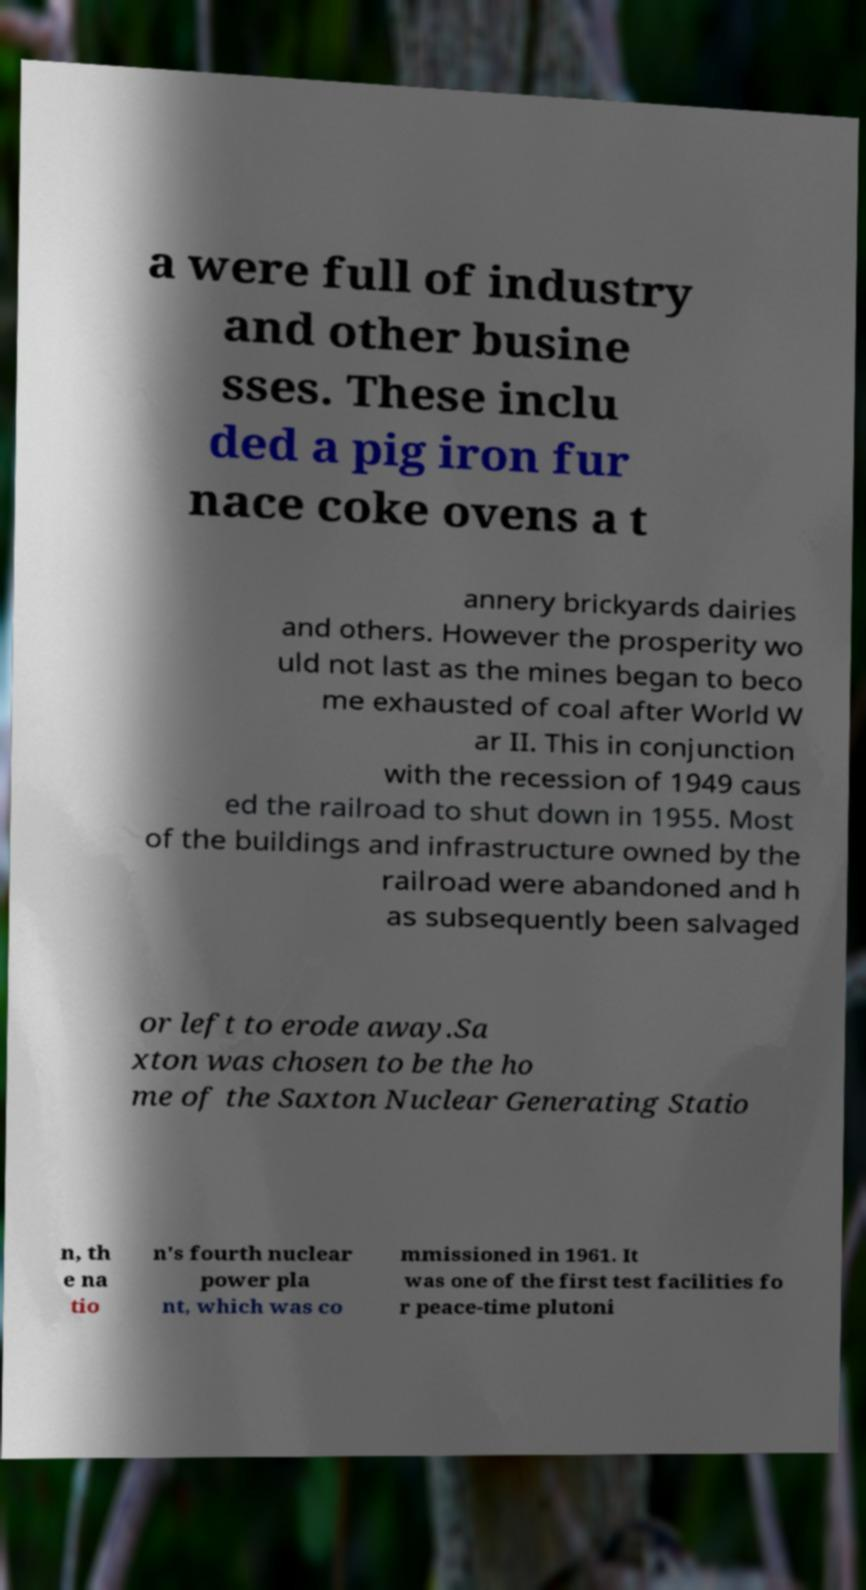For documentation purposes, I need the text within this image transcribed. Could you provide that? a were full of industry and other busine sses. These inclu ded a pig iron fur nace coke ovens a t annery brickyards dairies and others. However the prosperity wo uld not last as the mines began to beco me exhausted of coal after World W ar II. This in conjunction with the recession of 1949 caus ed the railroad to shut down in 1955. Most of the buildings and infrastructure owned by the railroad were abandoned and h as subsequently been salvaged or left to erode away.Sa xton was chosen to be the ho me of the Saxton Nuclear Generating Statio n, th e na tio n's fourth nuclear power pla nt, which was co mmissioned in 1961. It was one of the first test facilities fo r peace-time plutoni 